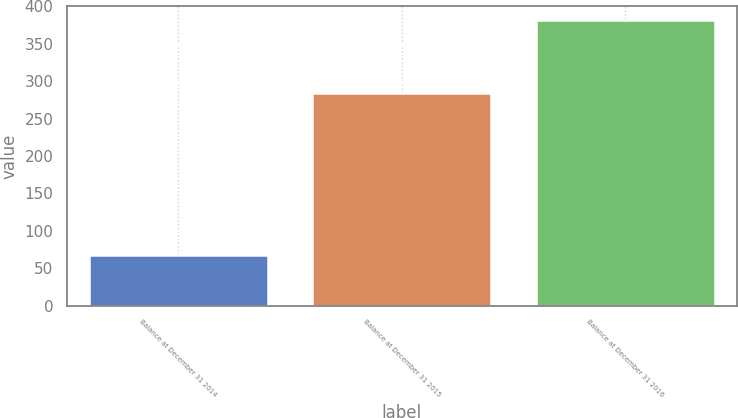Convert chart to OTSL. <chart><loc_0><loc_0><loc_500><loc_500><bar_chart><fcel>Balance at December 31 2014<fcel>Balance at December 31 2015<fcel>Balance at December 31 2016<nl><fcel>68<fcel>284<fcel>381<nl></chart> 